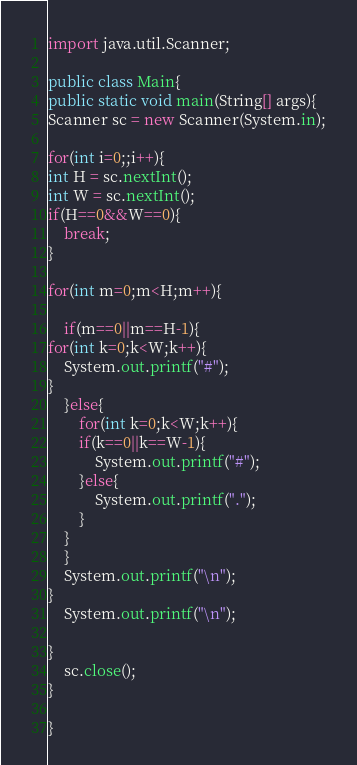Convert code to text. <code><loc_0><loc_0><loc_500><loc_500><_Java_>import java.util.Scanner;

public class Main{
public static void main(String[] args){
Scanner sc = new Scanner(System.in);

for(int i=0;;i++){
int H = sc.nextInt();
int W = sc.nextInt();
if(H==0&&W==0){
    break;
}

for(int m=0;m<H;m++){

    if(m==0||m==H-1){
for(int k=0;k<W;k++){
    System.out.printf("#");
}
    }else{
        for(int k=0;k<W;k++){
        if(k==0||k==W-1){
            System.out.printf("#");
        }else{
            System.out.printf(".");
        }
    }
    }
    System.out.printf("\n");
}
    System.out.printf("\n");

}
    sc.close();
}

}
</code> 